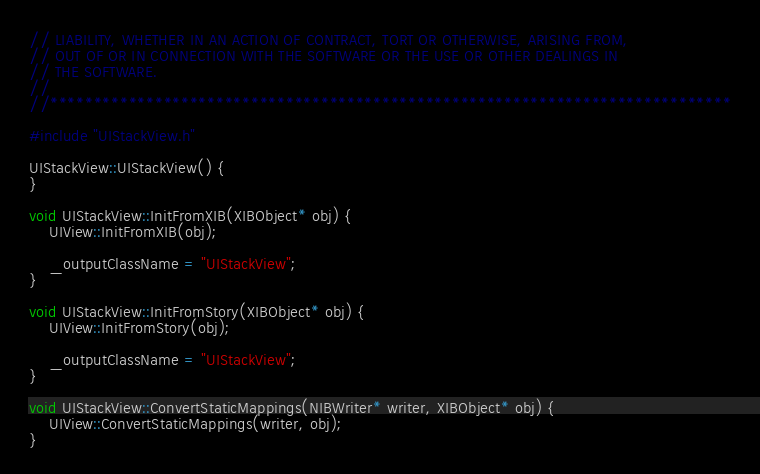Convert code to text. <code><loc_0><loc_0><loc_500><loc_500><_C++_>// LIABILITY, WHETHER IN AN ACTION OF CONTRACT, TORT OR OTHERWISE, ARISING FROM,
// OUT OF OR IN CONNECTION WITH THE SOFTWARE OR THE USE OR OTHER DEALINGS IN
// THE SOFTWARE.
//
//******************************************************************************

#include "UIStackView.h"

UIStackView::UIStackView() {
}

void UIStackView::InitFromXIB(XIBObject* obj) {
    UIView::InitFromXIB(obj);

    _outputClassName = "UIStackView";
}

void UIStackView::InitFromStory(XIBObject* obj) {
    UIView::InitFromStory(obj);

    _outputClassName = "UIStackView";
}

void UIStackView::ConvertStaticMappings(NIBWriter* writer, XIBObject* obj) {
    UIView::ConvertStaticMappings(writer, obj);
}
</code> 